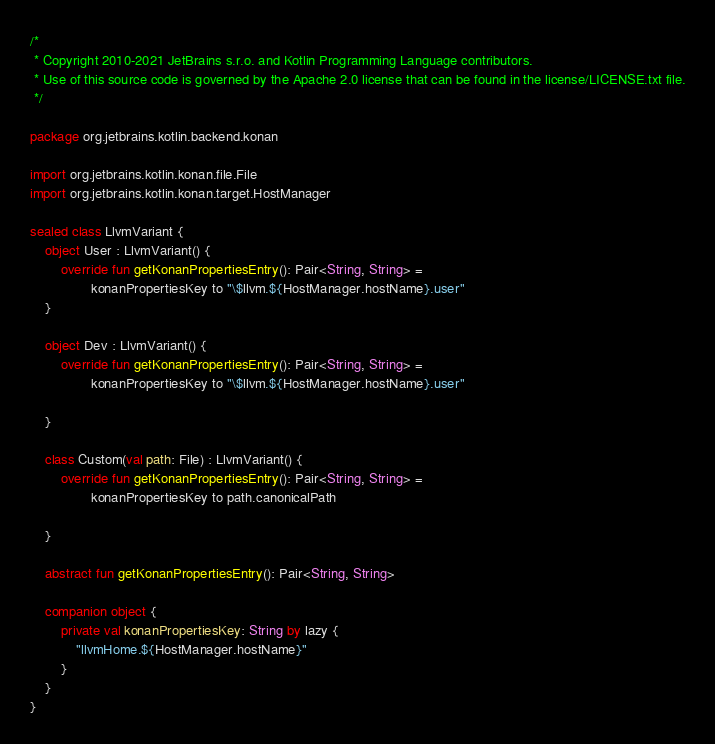<code> <loc_0><loc_0><loc_500><loc_500><_Kotlin_>/*
 * Copyright 2010-2021 JetBrains s.r.o. and Kotlin Programming Language contributors.
 * Use of this source code is governed by the Apache 2.0 license that can be found in the license/LICENSE.txt file.
 */

package org.jetbrains.kotlin.backend.konan

import org.jetbrains.kotlin.konan.file.File
import org.jetbrains.kotlin.konan.target.HostManager

sealed class LlvmVariant {
    object User : LlvmVariant() {
        override fun getKonanPropertiesEntry(): Pair<String, String> =
                konanPropertiesKey to "\$llvm.${HostManager.hostName}.user"
    }

    object Dev : LlvmVariant() {
        override fun getKonanPropertiesEntry(): Pair<String, String> =
                konanPropertiesKey to "\$llvm.${HostManager.hostName}.user"

    }

    class Custom(val path: File) : LlvmVariant() {
        override fun getKonanPropertiesEntry(): Pair<String, String> =
                konanPropertiesKey to path.canonicalPath

    }

    abstract fun getKonanPropertiesEntry(): Pair<String, String>

    companion object {
        private val konanPropertiesKey: String by lazy {
            "llvmHome.${HostManager.hostName}"
        }
    }
}
</code> 